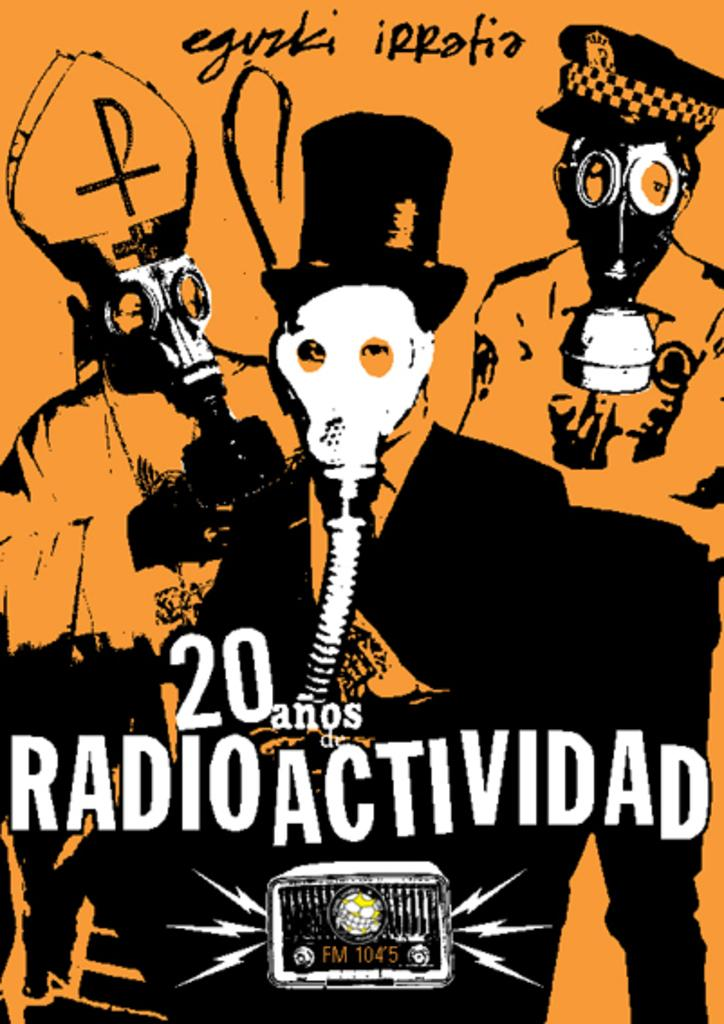What type of visual representation is the image? The image is a poster. What subjects are depicted on the poster? There are depictions of humans on the poster. Are there any words or phrases on the poster? Yes, there is text on the poster. What object is also shown on the poster? There is a radio depicted on the poster. How many jars of jelly are visible on the poster? There are no jars of jelly present on the poster. Are there any mice depicted on the poster? There are no mice depicted on the poster. 